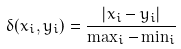<formula> <loc_0><loc_0><loc_500><loc_500>\delta ( x _ { i } , y _ { i } ) = \frac { | x _ { i } - y _ { i } | } { \max _ { i } - \min _ { i } }</formula> 